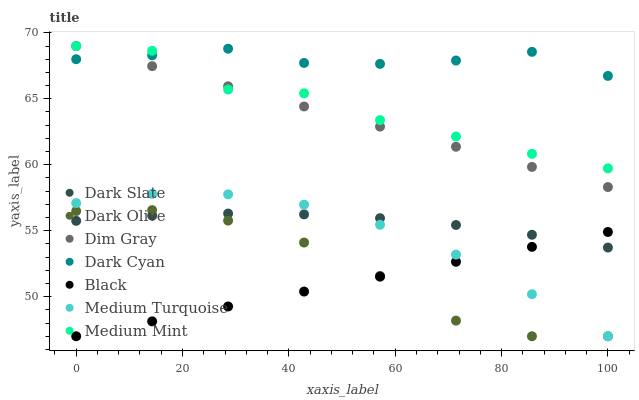Does Black have the minimum area under the curve?
Answer yes or no. Yes. Does Dark Cyan have the maximum area under the curve?
Answer yes or no. Yes. Does Dim Gray have the minimum area under the curve?
Answer yes or no. No. Does Dim Gray have the maximum area under the curve?
Answer yes or no. No. Is Black the smoothest?
Answer yes or no. Yes. Is Medium Mint the roughest?
Answer yes or no. Yes. Is Dim Gray the smoothest?
Answer yes or no. No. Is Dim Gray the roughest?
Answer yes or no. No. Does Dark Olive have the lowest value?
Answer yes or no. Yes. Does Dim Gray have the lowest value?
Answer yes or no. No. Does Dim Gray have the highest value?
Answer yes or no. Yes. Does Dark Olive have the highest value?
Answer yes or no. No. Is Black less than Dim Gray?
Answer yes or no. Yes. Is Dim Gray greater than Black?
Answer yes or no. Yes. Does Medium Turquoise intersect Dark Slate?
Answer yes or no. Yes. Is Medium Turquoise less than Dark Slate?
Answer yes or no. No. Is Medium Turquoise greater than Dark Slate?
Answer yes or no. No. Does Black intersect Dim Gray?
Answer yes or no. No. 